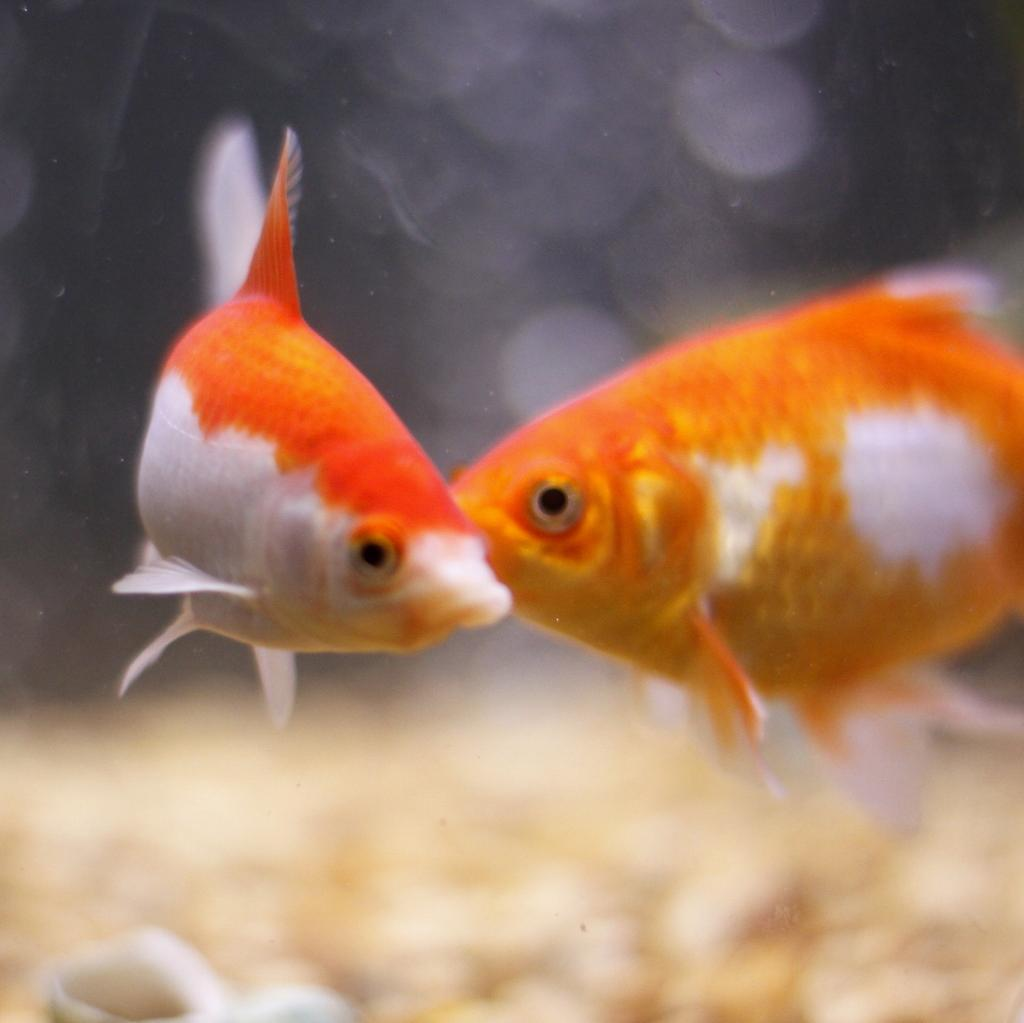How many fishes are in the image? There are two fishes in the image. What colors are the fishes? One fish is orange in color, and the other fish is white in color. What type of copper material can be seen in the image? There is no copper material present in the image; it features two fishes of different colors. What are the hands of the fishes doing in the image? Fishes do not have hands, so this question is not applicable to the image. 